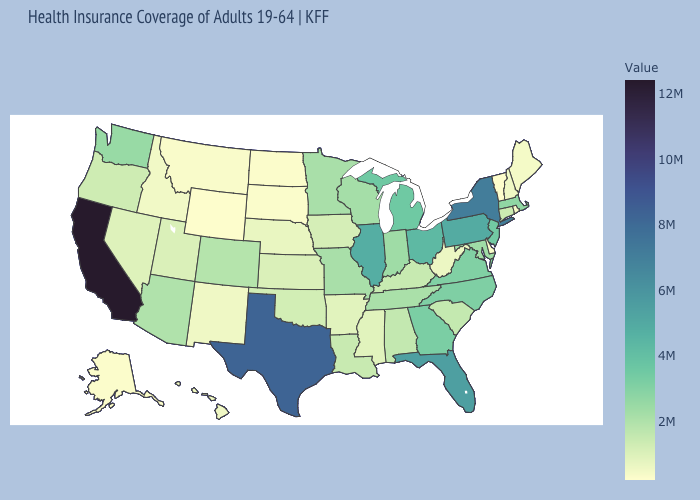Which states have the lowest value in the USA?
Short answer required. Vermont. Does Illinois have the highest value in the MidWest?
Give a very brief answer. Yes. Which states hav the highest value in the South?
Keep it brief. Texas. Does West Virginia have a lower value than North Carolina?
Quick response, please. Yes. Does Kentucky have a higher value than Florida?
Short answer required. No. Does New Hampshire have a lower value than Minnesota?
Quick response, please. Yes. 